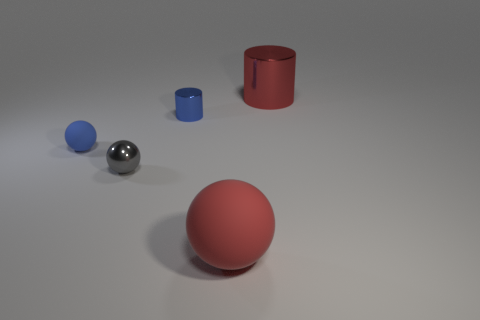The big metal thing that is the same color as the big rubber sphere is what shape?
Your answer should be compact. Cylinder. Are there more blue shiny cylinders that are to the left of the blue sphere than big rubber objects?
Ensure brevity in your answer.  No. The red sphere that is the same material as the blue ball is what size?
Your answer should be compact. Large. Are there any tiny shiny balls that have the same color as the large rubber ball?
Your response must be concise. No. What number of objects are small blue things or spheres to the left of the red rubber ball?
Make the answer very short. 3. Are there more blue balls than small brown metallic blocks?
Keep it short and to the point. Yes. What is the size of the thing that is the same color as the big sphere?
Provide a succinct answer. Large. Are there any big things made of the same material as the gray ball?
Your answer should be very brief. Yes. What shape is the thing that is in front of the blue sphere and on the right side of the small gray ball?
Provide a short and direct response. Sphere. What number of other things are the same shape as the big red metal object?
Offer a very short reply. 1. 